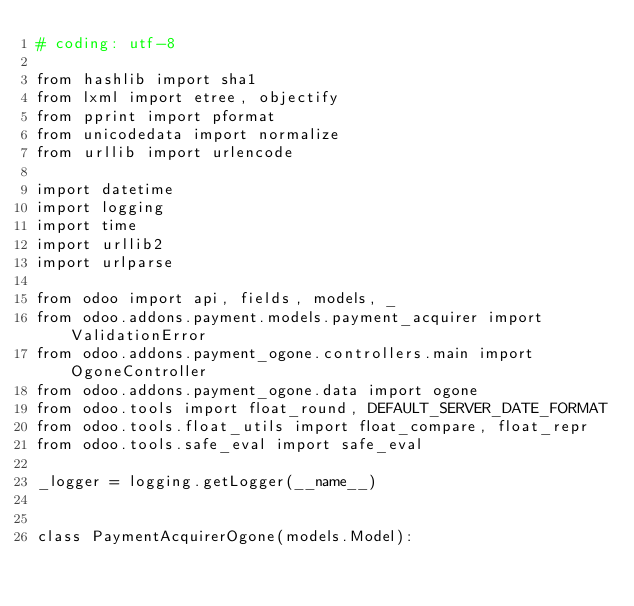Convert code to text. <code><loc_0><loc_0><loc_500><loc_500><_Python_># coding: utf-8

from hashlib import sha1
from lxml import etree, objectify
from pprint import pformat
from unicodedata import normalize
from urllib import urlencode

import datetime
import logging
import time
import urllib2
import urlparse

from odoo import api, fields, models, _
from odoo.addons.payment.models.payment_acquirer import ValidationError
from odoo.addons.payment_ogone.controllers.main import OgoneController
from odoo.addons.payment_ogone.data import ogone
from odoo.tools import float_round, DEFAULT_SERVER_DATE_FORMAT
from odoo.tools.float_utils import float_compare, float_repr
from odoo.tools.safe_eval import safe_eval

_logger = logging.getLogger(__name__)


class PaymentAcquirerOgone(models.Model):</code> 